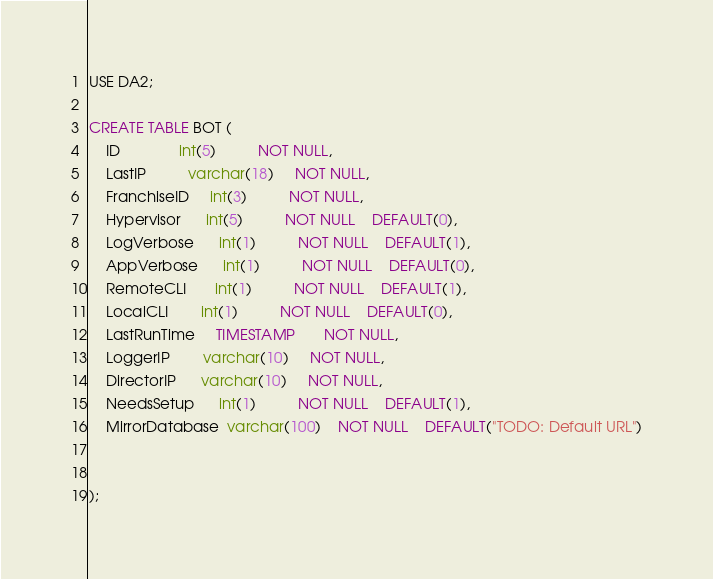<code> <loc_0><loc_0><loc_500><loc_500><_SQL_>USE DA2;

CREATE TABLE BOT (
    ID              int(5)          NOT NULL,
    LastIP          varchar(18)     NOT NULL,
    FranchiseID     int(3)          NOT NULL,
    Hypervisor      int(5)          NOT NULL    DEFAULT(0),
    LogVerbose      int(1)          NOT NULL    DEFAULT(1),
    AppVerbose      int(1)          NOT NULL    DEFAULT(0),
    RemoteCLI       int(1)          NOT NULL    DEFAULT(1),
    LocalCLI        int(1)          NOT NULL    DEFAULT(0),
    LastRunTime     TIMESTAMP       NOT NULL,
    LoggerIP        varchar(10)     NOT NULL,
    DirectorIP      varchar(10)     NOT NULL,
    NeedsSetup      int(1)          NOT NULL    DEFAULT(1),
    MirrorDatabase  varchar(100)    NOT NULL    DEFAULT("TODO: Default URL")


);</code> 